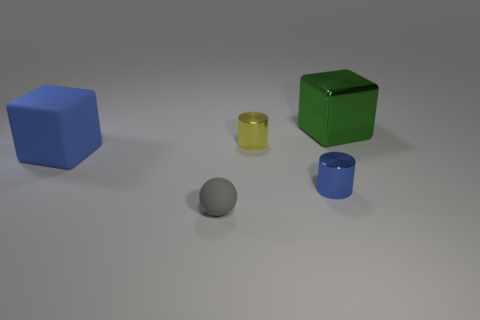Add 3 yellow things. How many objects exist? 8 Subtract all cylinders. How many objects are left? 3 Add 5 green metallic objects. How many green metallic objects exist? 6 Subtract 0 yellow balls. How many objects are left? 5 Subtract all gray balls. Subtract all matte blocks. How many objects are left? 3 Add 4 yellow metallic things. How many yellow metallic things are left? 5 